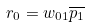<formula> <loc_0><loc_0><loc_500><loc_500>r _ { 0 } = w _ { 0 1 } \overline { p _ { 1 } }</formula> 